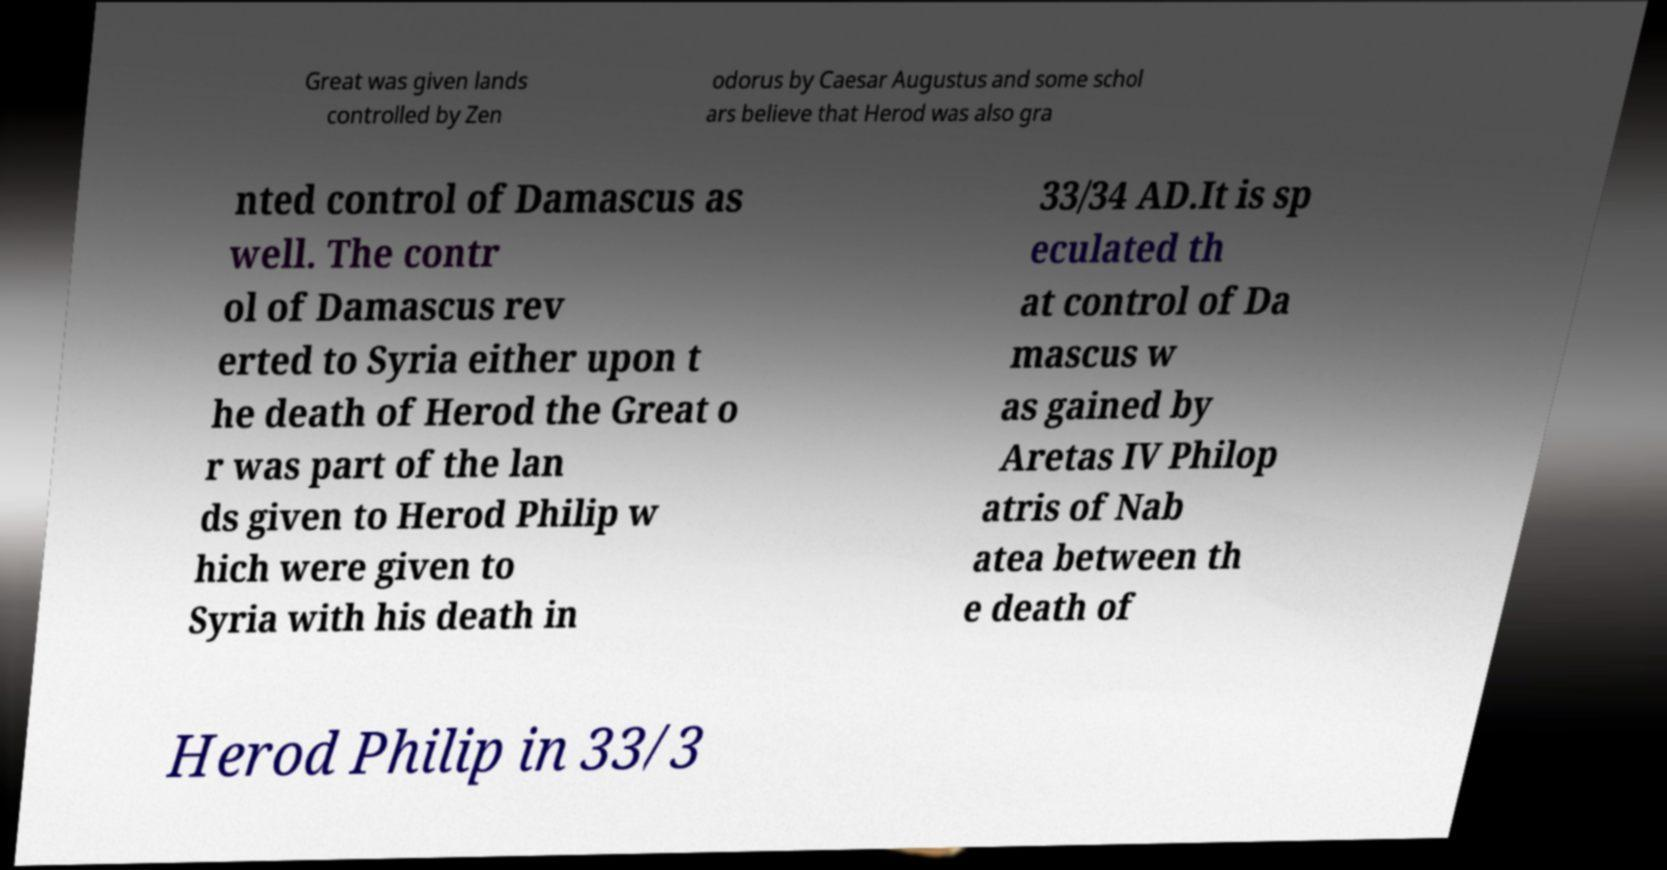Could you extract and type out the text from this image? Great was given lands controlled by Zen odorus by Caesar Augustus and some schol ars believe that Herod was also gra nted control of Damascus as well. The contr ol of Damascus rev erted to Syria either upon t he death of Herod the Great o r was part of the lan ds given to Herod Philip w hich were given to Syria with his death in 33/34 AD.It is sp eculated th at control of Da mascus w as gained by Aretas IV Philop atris of Nab atea between th e death of Herod Philip in 33/3 